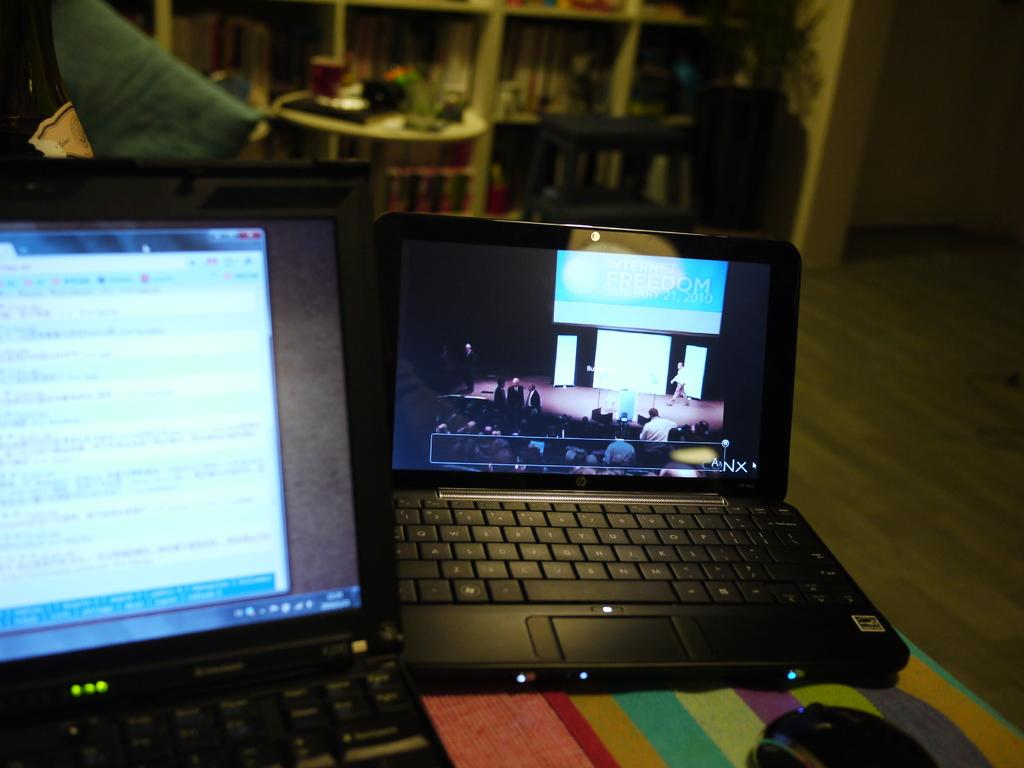<image>
Create a compact narrative representing the image presented. two lap top computers with open screens, one reads "Internet Freedom January 21, 2010" 